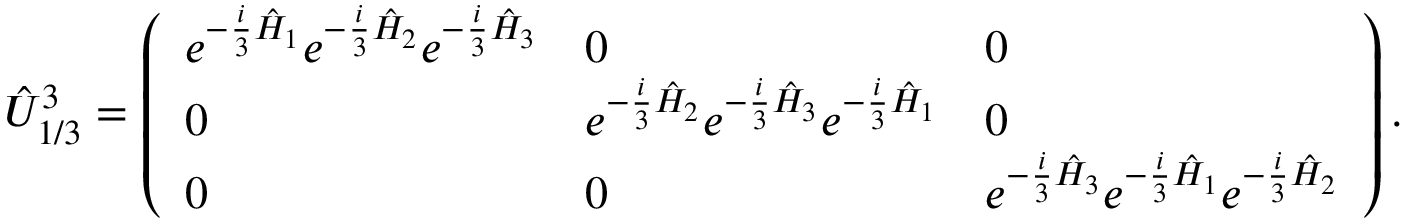<formula> <loc_0><loc_0><loc_500><loc_500>\hat { U } _ { 1 / 3 } ^ { 3 } = \left ( \begin{array} { l l l } { e ^ { - \frac { i } { 3 } \hat { H } _ { 1 } } e ^ { - \frac { i } { 3 } \hat { H } _ { 2 } } e ^ { - \frac { i } { 3 } \hat { H } _ { 3 } } } & { 0 } & { 0 } \\ { 0 } & { e ^ { - \frac { i } { 3 } \hat { H } _ { 2 } } e ^ { - \frac { i } { 3 } \hat { H } _ { 3 } } e ^ { - \frac { i } { 3 } \hat { H } _ { 1 } } } & { 0 } \\ { 0 } & { 0 } & { e ^ { - \frac { i } { 3 } \hat { H } _ { 3 } } e ^ { - \frac { i } { 3 } \hat { H } _ { 1 } } e ^ { - \frac { i } { 3 } \hat { H } _ { 2 } } } \end{array} \right ) .</formula> 